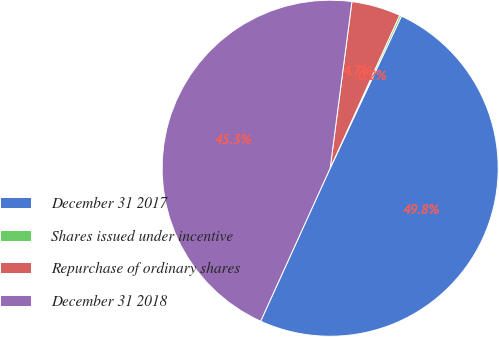<chart> <loc_0><loc_0><loc_500><loc_500><pie_chart><fcel>December 31 2017<fcel>Shares issued under incentive<fcel>Repurchase of ordinary shares<fcel>December 31 2018<nl><fcel>49.81%<fcel>0.19%<fcel>4.72%<fcel>45.28%<nl></chart> 